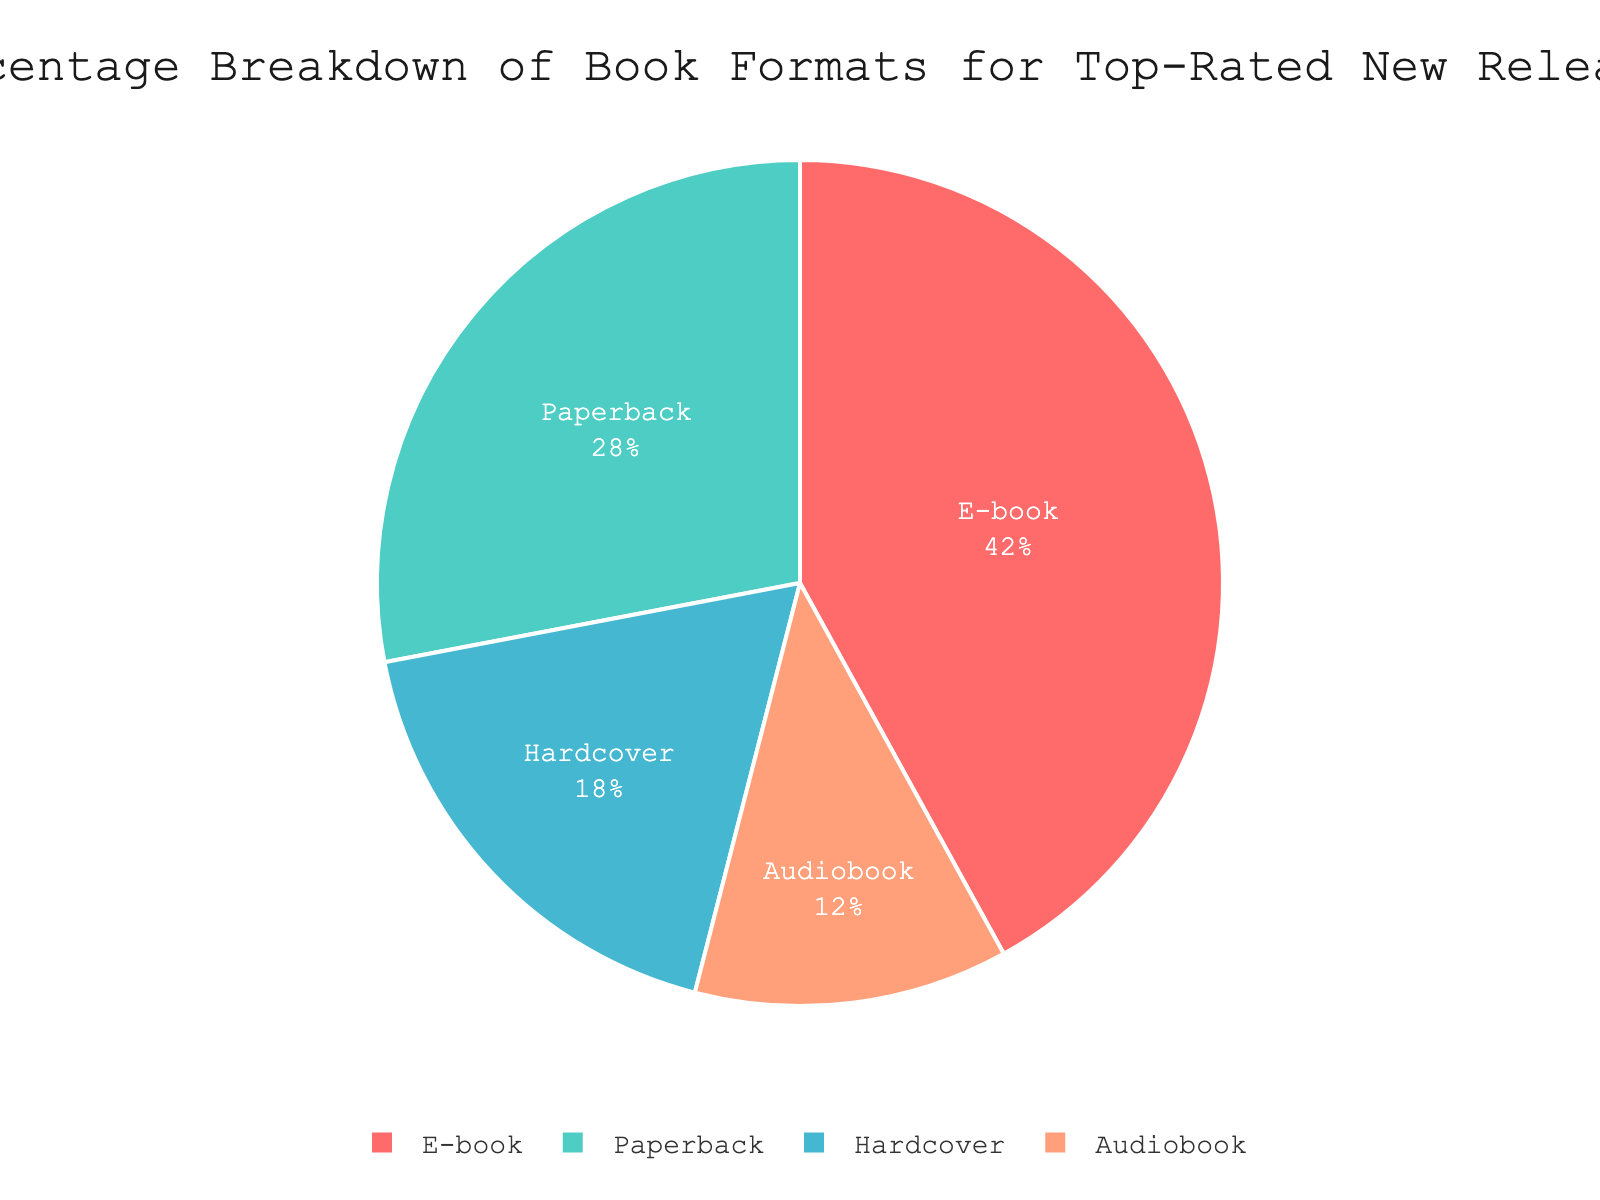What percentage of top-rated new releases are in e-book format? The pie chart shows that the section for e-book format occupies 42% of the total chart.
Answer: 42% Which book format has the smallest percentage of top-rated new releases? The pie chart indicates that the audiobook segment is the smallest, occupying only 12% of the chart.
Answer: Audiobook How much larger is the percentage of e-books compared to audiobooks in top-rated new releases? The percentage of e-books is 42%, and the percentage of audiobooks is 12%. The difference is 42 - 12.
Answer: 30% Are there more paperbacks or hardcovers in top-rated new releases, and by how much? The percentage for paperbacks is 28%, and for hardcovers, it is 18%. Subtracting these gives 28 - 18.
Answer: Paperbacks by 10% What is the combined percentage of paperback and hardcover formats? The percentage for paperbacks is 28%, and for hardcovers, it is 18%. Adding these gives 28 + 18.
Answer: 46% Which section is represented by the color red? The color red in the pie chart corresponds to the e-book format, as indicated by its label and percentage.
Answer: E-book How do the percentages of paperbacks and audiobooks together compare to the percentage of e-books? The percentages for paperbacks and audiobooks are 28% and 12%, respectively. Together, they make 28 + 12 = 40%, which is 2% less than the e-book percentage of 42%.
Answer: 2% less If you were to remove the hardcover section, what would the new total percentage of the remaining formats be? Removing the hardcover's 18% from the total 100% leaves 100 - 18.
Answer: 82% What percentage of book formats other than e-books are in top-rated new releases? The percentages for paperbacks, hardcovers, and audiobooks are 28%, 18%, and 12%, respectively. Adding these gives 28 + 18 + 12.
Answer: 58% Which book format has nearly double the percentage of another format, and what are those percentages? The e-book percentage is 42%, which is nearly double the audiobook percentage of 12% (42 ≈ 2 * 12).
Answer: E-book (42%) and Audiobook (12%) 